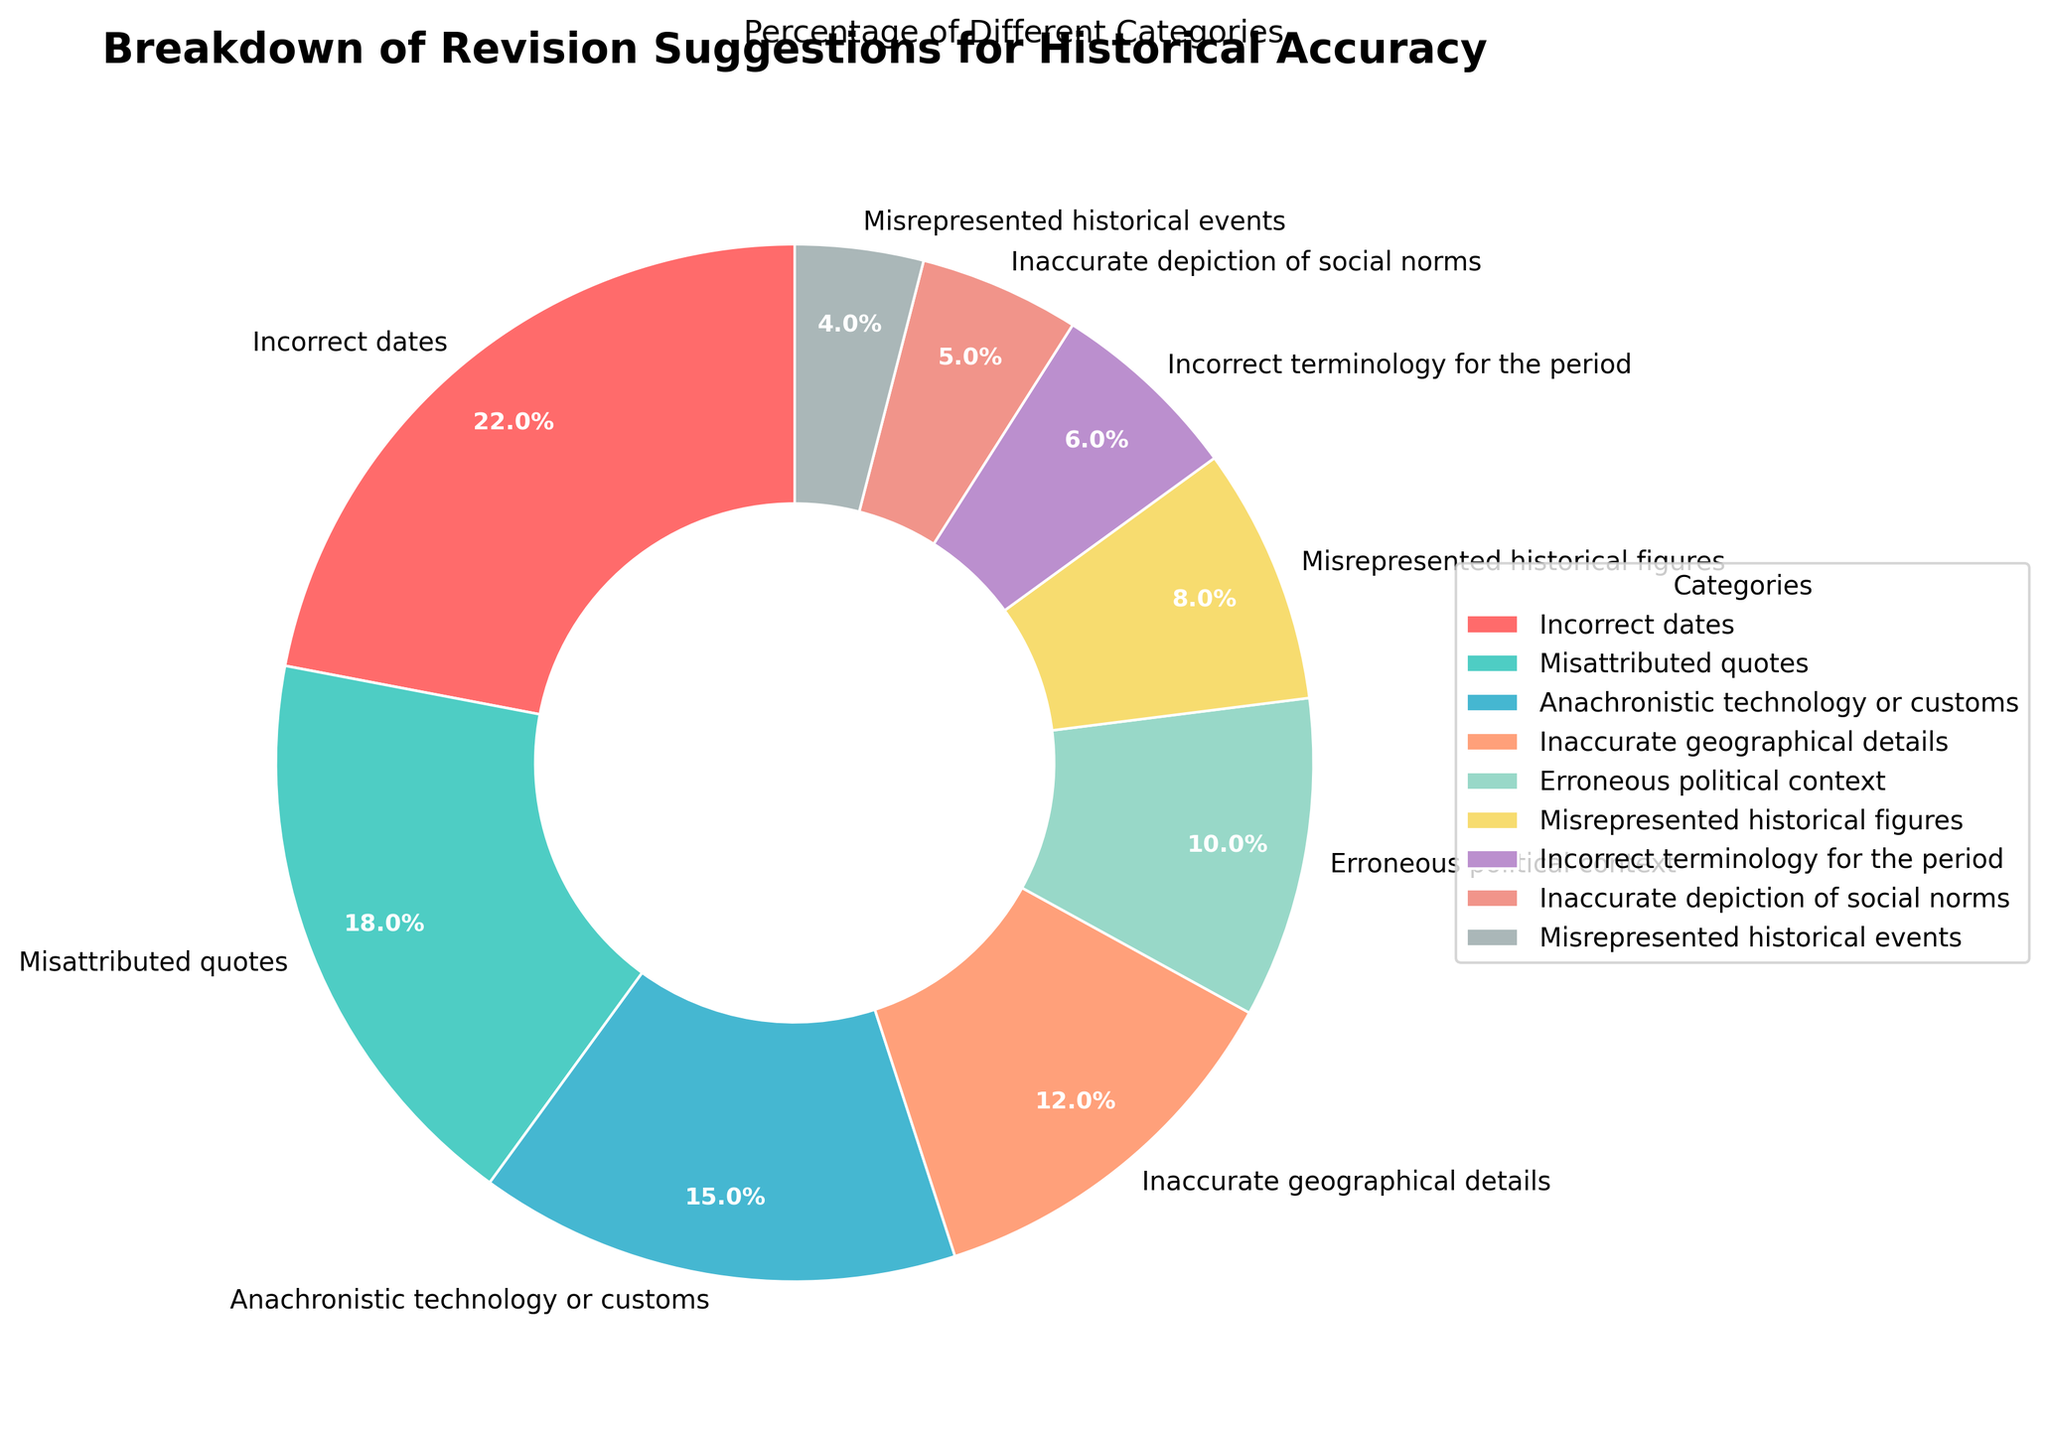Which category has the highest percentage? The category with the highest percentage can be found by looking at the segment that occupies the largest portion of the pie chart. The "Incorrect dates" category has the largest slice.
Answer: Incorrect dates What is the combined percentage of "Misattributed quotes" and "Anachronistic technology or customs"? Add the percentages of "Misattributed quotes" (18%) and "Anachronistic technology or customs" (15%) together: 18 + 15 = 33.
Answer: 33% Which category has the smallest percentage? The segment occupying the smallest portion of the pie chart represents the category with the lowest percentage. "Misrepresented historical events" has the smallest slice.
Answer: Misrepresented historical events Are there more revision suggestions for "Misrepresented historical figures" or "Inaccurate geographical details"? Compare the percentages of "Misrepresented historical figures" (8%) and "Inaccurate geographical details" (12%). Since 12% is greater than 8%, there are more revision suggestions for "Inaccurate geographical details."
Answer: Inaccurate geographical details What is the difference in the percentage of "Erroneous political context" and "Incorrect terminology for the period"? Subtract the percentage of "Incorrect terminology for the period" (6%) from "Erroneous political context" (10%): 10 - 6 = 4.
Answer: 4% What is the total percentage of the top three categories? Sum the percentages of the top three categories: "Incorrect dates" (22%), "Misattributed quotes" (18%), and "Anachronistic technology or customs" (15%): 22 + 18 + 15 = 55.
Answer: 55% How many categories have a percentage less than 10%? Identify the categories with percentages less than 10%: "Misrepresented historical figures" (8%), "Incorrect terminology for the period" (6%), "Inaccurate depiction of social norms" (5%), and "Misrepresented historical events" (4%). There are 4 such categories.
Answer: 4 Which category is represented by the red segment of the pie chart? By examining the color of each segment in the pie chart, it can be determined that the red segment corresponds to the "Incorrect dates" category.
Answer: Incorrect dates What is the average percentage of the categories "Inaccurate geographical details" and "Erroneous political context"? Find the average by summing the percentages of "Inaccurate geographical details" (12%) and "Erroneous political context" (10%), then dividing by 2: (12 + 10) / 2 = 11.
Answer: 11% Is the percentage for "Inaccurate depiction of social norms" greater than or equal to the percentage for "Misrepresented historical events"? Compare the percentages: "Inaccurate depiction of social norms" has 5% while "Misrepresented historical events" has 4%. Since 5% is greater than 4%, the answer is yes.
Answer: Yes 